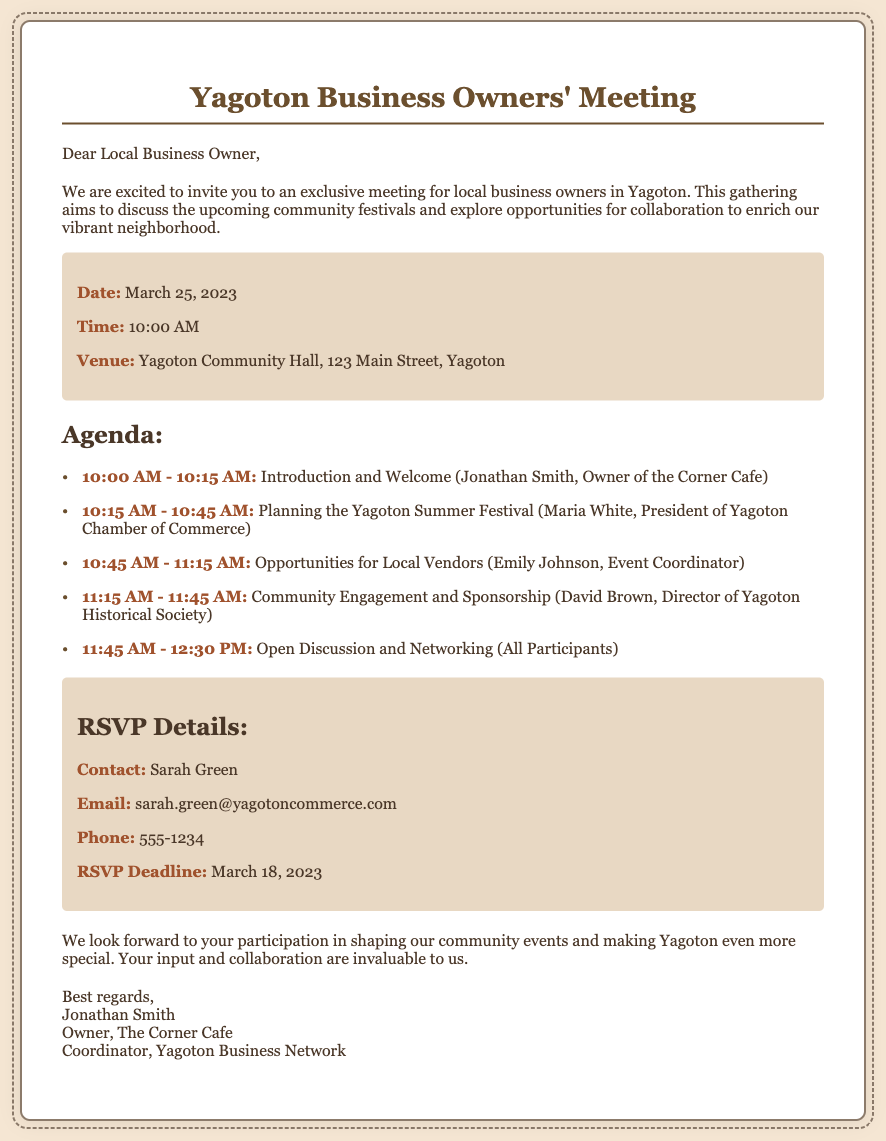What is the title of the meeting? The title of the meeting is explicitly mentioned in the header of the document.
Answer: Yagoton Business Owners' Meeting What is the date of the meeting? The date of the meeting is indicated in the meeting details section.
Answer: March 25, 2023 Who is the contact person for RSVPs? The name of the contact for RSVPs is provided in the RSVP details section.
Answer: Sarah Green What is the RSVP deadline? The deadline for RSVPs is clearly stated in the RSVP details section.
Answer: March 18, 2023 What is the venue for the meeting? The venue is detailed in the meeting details section along with its address.
Answer: Yagoton Community Hall, 123 Main Street, Yagoton Who will lead the introduction and welcome session? The document specifies who will lead the introduction during the meeting agenda.
Answer: Jonathan Smith, Owner of the Corner Cafe What time does the meeting start? The start time of the meeting is explicitly mentioned in the meeting details section.
Answer: 10:00 AM What is one of the agenda items related to? The document lists agenda items that outline the focus points of the meeting.
Answer: Planning the Yagoton Summer Festival How long is the Open Discussion and Networking session scheduled for? The duration of the Open Discussion and Networking session is detailed in the agenda section.
Answer: 45 minutes 